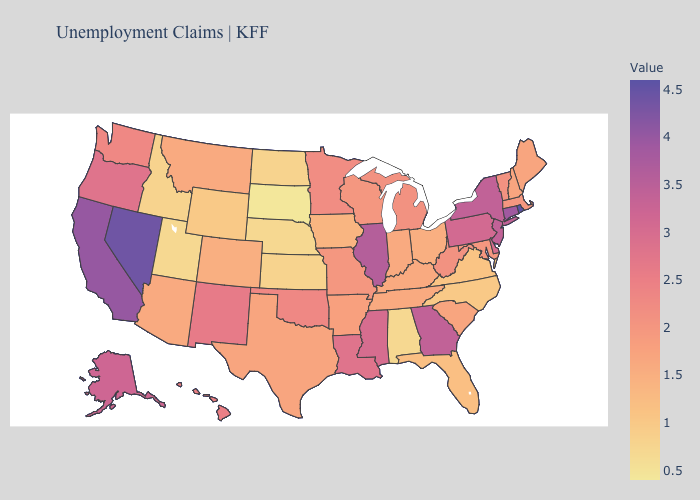Among the states that border Wisconsin , does Illinois have the highest value?
Concise answer only. Yes. Among the states that border New Hampshire , which have the lowest value?
Concise answer only. Maine. Among the states that border Virginia , which have the highest value?
Concise answer only. West Virginia. Does Massachusetts have the lowest value in the USA?
Be succinct. No. Does Maryland have a lower value than North Dakota?
Give a very brief answer. No. Does North Carolina have a lower value than Wisconsin?
Write a very short answer. Yes. 